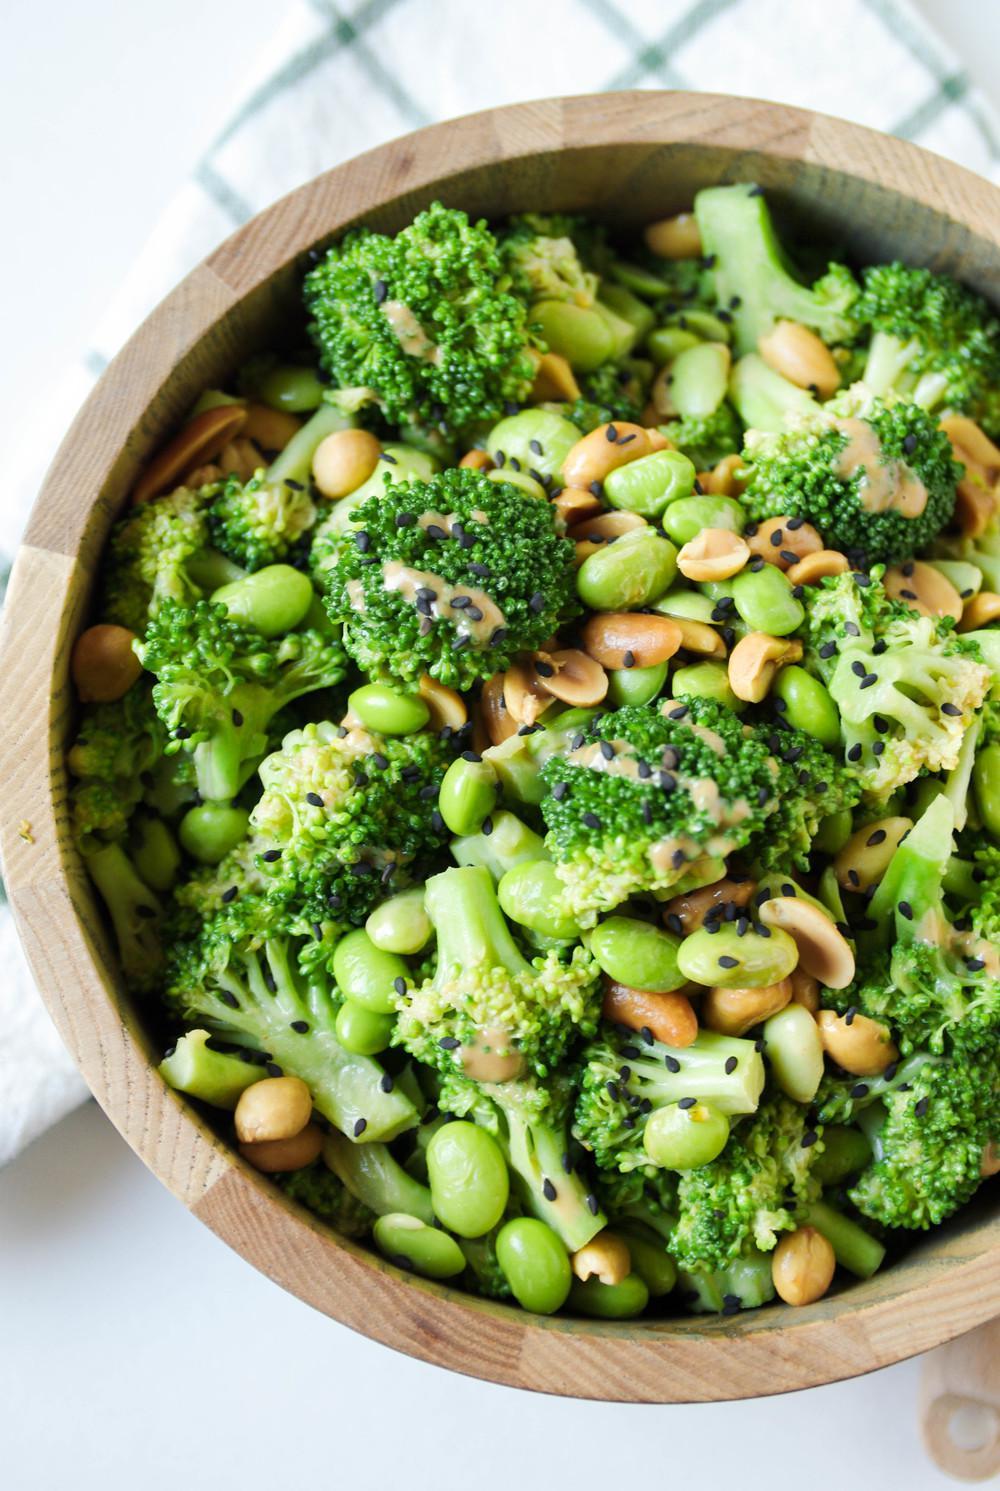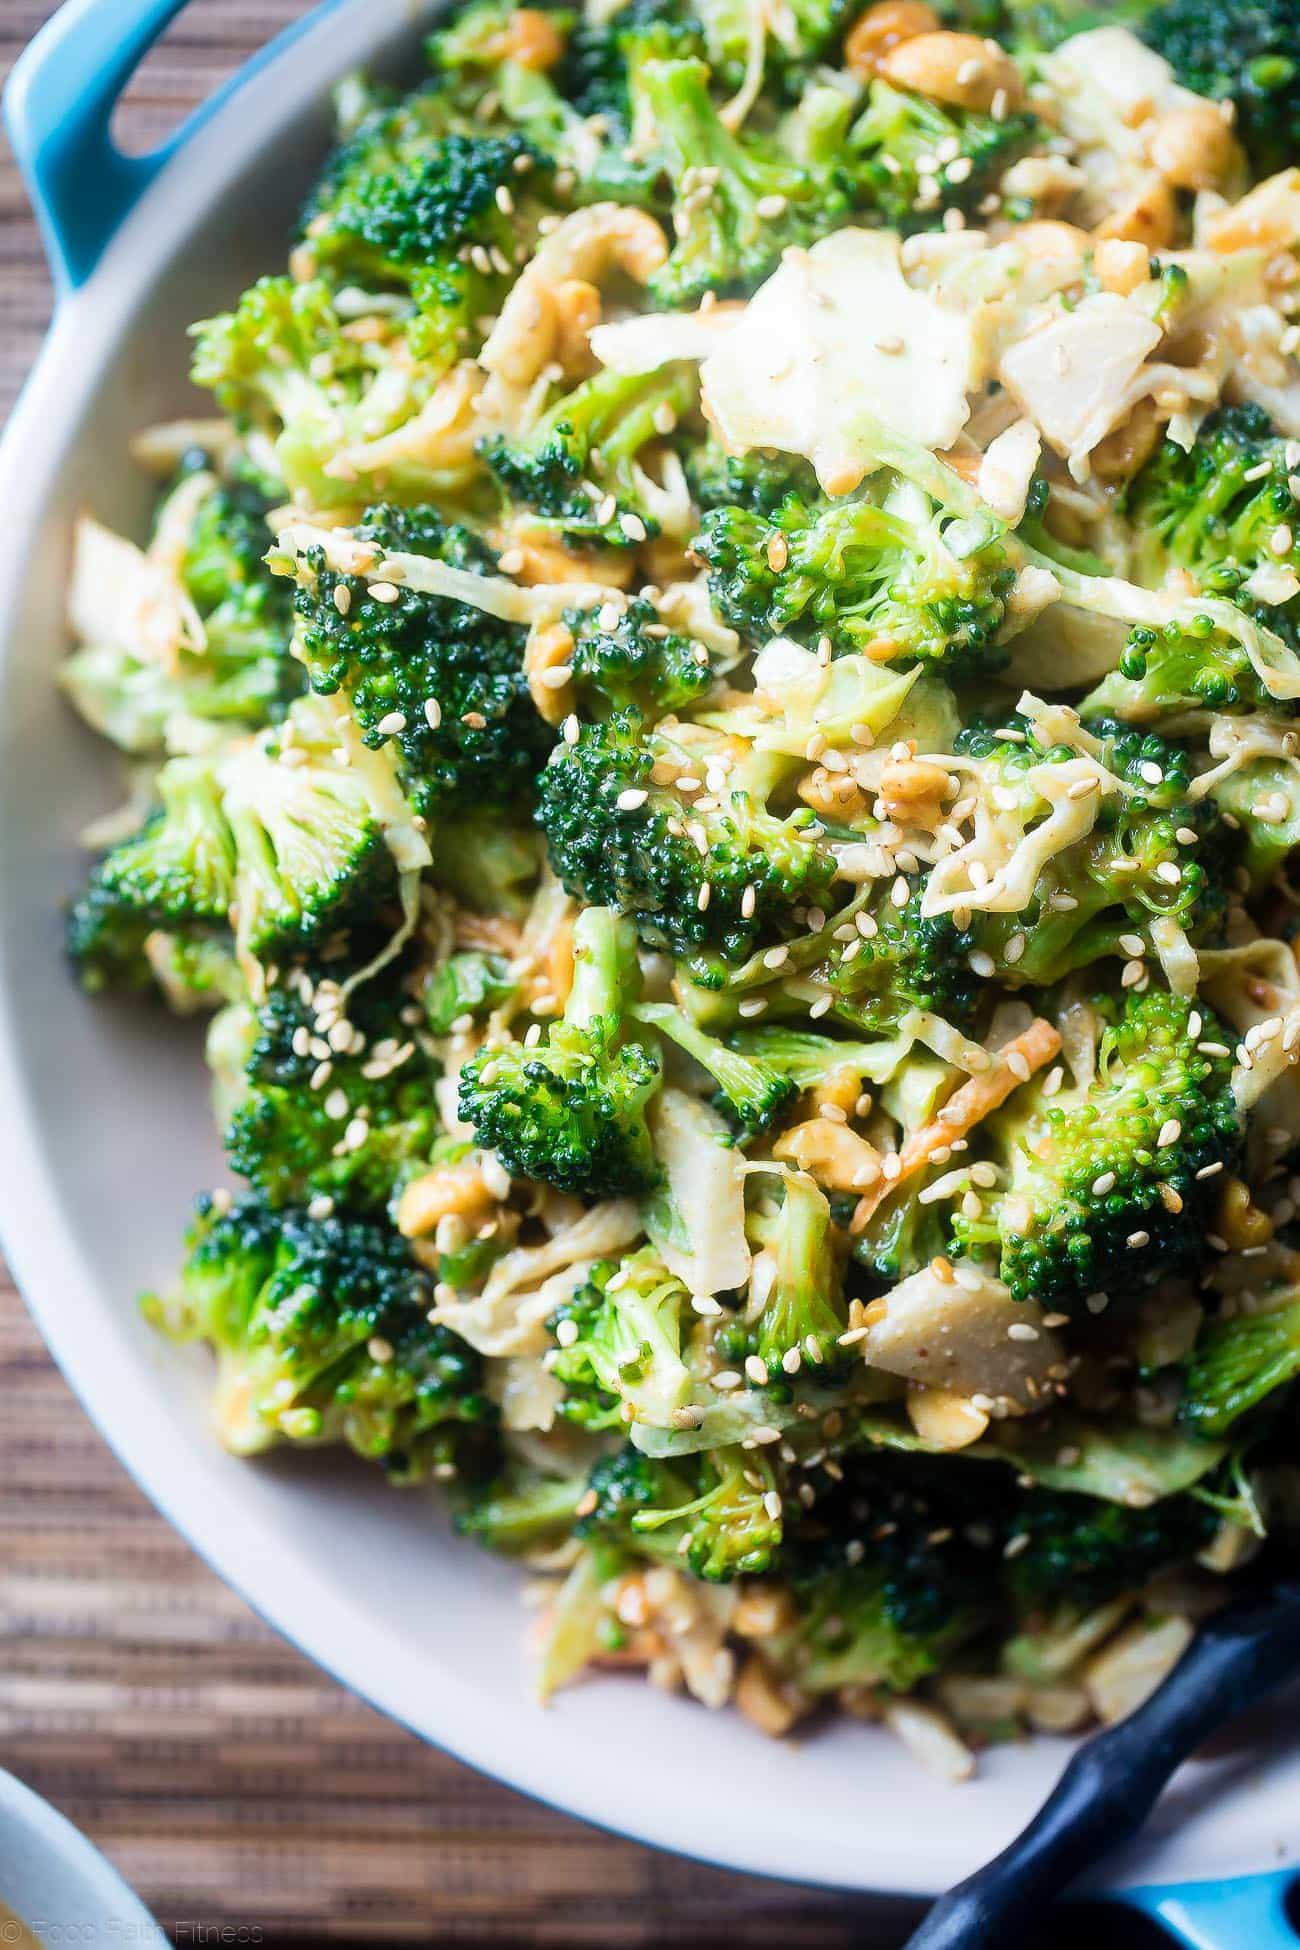The first image is the image on the left, the second image is the image on the right. Considering the images on both sides, is "One image shows a piece of silverware on the edge of a round white handle-less dish containing broccoli florets." valid? Answer yes or no. No. The first image is the image on the left, the second image is the image on the right. For the images shown, is this caption "The left and right image contains the same number of white bowls full of broccoli." true? Answer yes or no. No. 